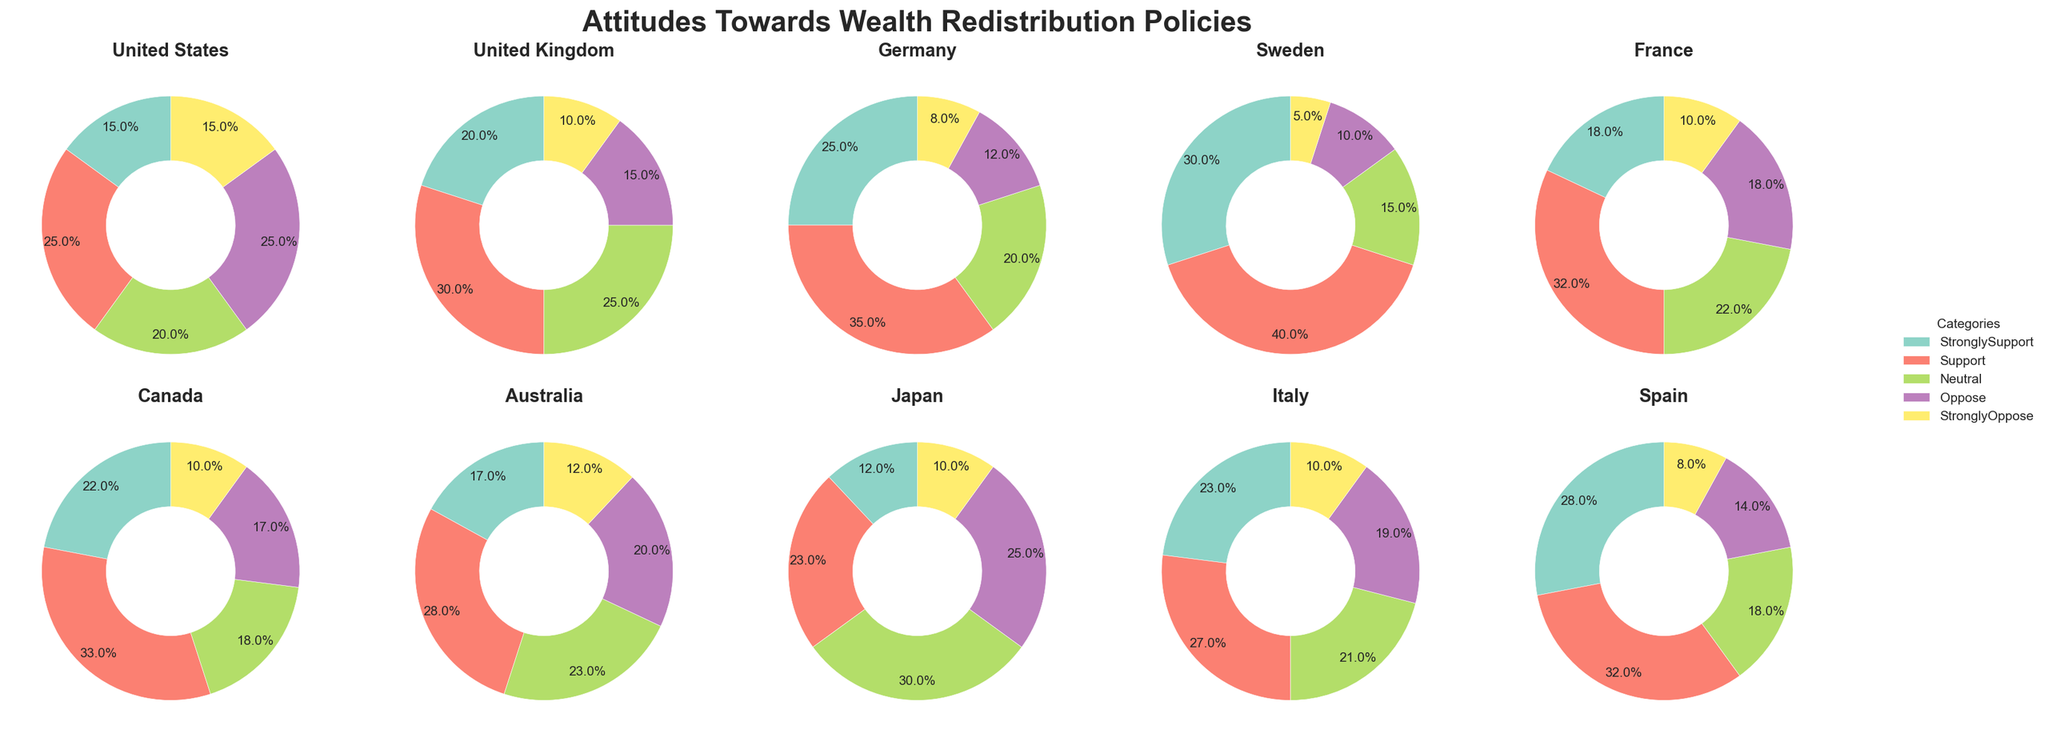What is the title of the figure? The title of the figure is usually located at the top and is often the largest text. Here, the text "Attitudes Towards Wealth Redistribution Policies" is at the top and is the largest.
Answer: Attitudes Towards Wealth Redistribution Policies Which country shows the highest percentage of strong support for wealth redistribution policies? To find the country with the highest strong support, locate the segment labeled as "StronglySupport" in each pie chart. Among all the pie charts, Sweden has the largest segment for "StronglySupport".
Answer: Sweden What are the colors used to represent the different response categories? The colors are consistent across all pie charts. They can be identified within the figure's legend, which maps each color to a category. Colors represent categories such as StronglySupport, Support, Neutral, Oppose, and StronglyOppose.
Answer: Various colors from the Set3 colormap Which country has the smallest percentage of neutral respondents? Examine the "Neutral" segment in each pie chart and find the country with the smallest. Sweden's Neutral segment is the smallest in comparison to others.
Answer: Sweden How many countries have a higher percentage of respondents that support rather than oppose wealth redistribution policies? Count the countries where the combined percentage of "StronglySupport" and "Support" is greater than the combined percentage of "Oppose" and "StronglyOppose." These countries are Sweden, Germany, United Kingdom, France, Canada, Spain, and Italy.
Answer: 7 Which country has an equal percentage of respondents who oppose and strongly support wealth redistribution policies? Look for the pie chart where the "Oppose" and "StronglySupport" segments have equal percentages. The United States shows 15% for both categories.
Answer: United States Compare the percentage of respondents who support wealth redistribution policies in France and Germany. Which country has a higher percentage? Compare the “Support” segment in each pie chart for France and Germany. Germany has a higher percentage at 35% compared to France's 32%.
Answer: Germany What is the total percentage of respondents who are neutral towards wealth redistribution policies in Japan and Australia combined? Add the "Neutral" percentages from Japan and Australia. Japan has 30% Neutral and Australia has 23% Neutral. 30% + 23% = 53%.
Answer: 53% Which country has the highest ratio of strong support to strong opposition? To calculate the ratio of "StronglySupport" to "StronglyOppose", divide the percentage of StronglySupport by the percentage of StronglyOppose for each country. Sweden's ratio is the highest with 30/5 = 6.
Answer: Sweden 